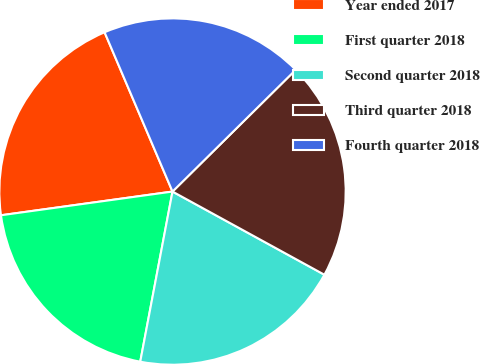Convert chart. <chart><loc_0><loc_0><loc_500><loc_500><pie_chart><fcel>Year ended 2017<fcel>First quarter 2018<fcel>Second quarter 2018<fcel>Third quarter 2018<fcel>Fourth quarter 2018<nl><fcel>20.77%<fcel>19.83%<fcel>20.01%<fcel>20.38%<fcel>19.01%<nl></chart> 